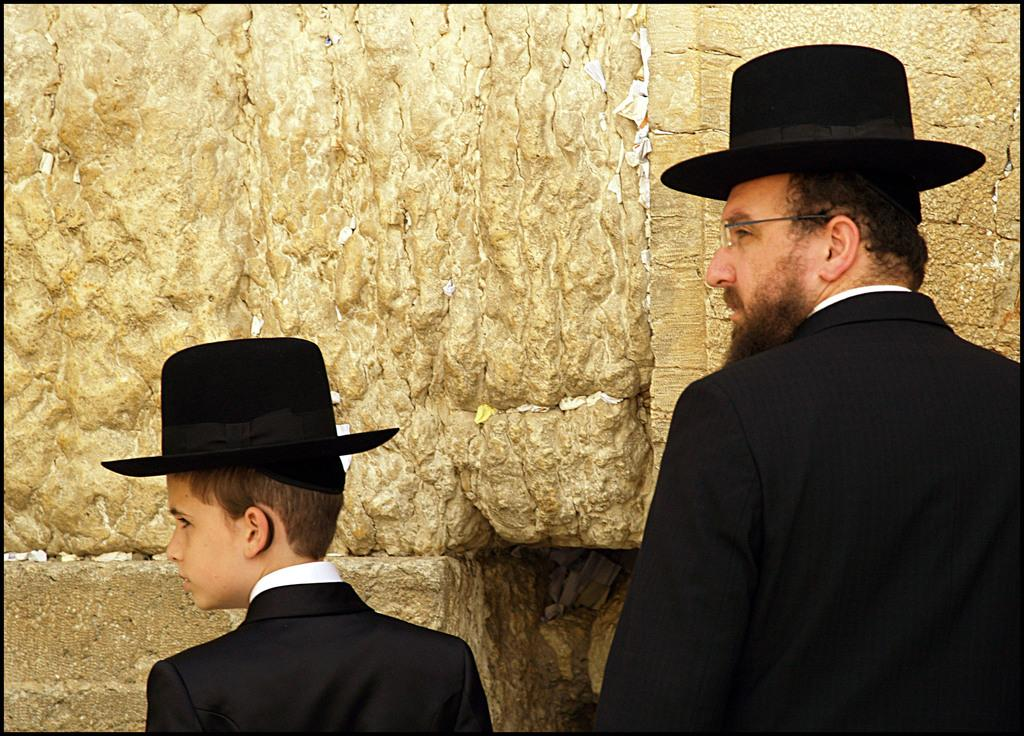How many people are in the image? There are two people in the image. What are the two people doing in the image? The two people are standing. What are the two people wearing on their heads? The two people are wearing black hats. What is in front of the two people? There is a wall in front of the two people. What type of scissors can be seen cutting the fairies' wings in the image? There are no scissors or fairies present in the image. Can you describe the flight of the two people in the image? The two people are standing, so there is no flight depicted in the image. 